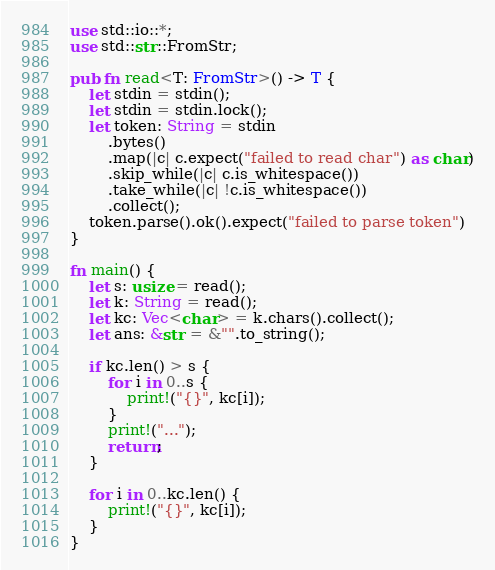Convert code to text. <code><loc_0><loc_0><loc_500><loc_500><_Rust_>use std::io::*;
use std::str::FromStr;

pub fn read<T: FromStr>() -> T {
    let stdin = stdin();
    let stdin = stdin.lock();
    let token: String = stdin
        .bytes()
        .map(|c| c.expect("failed to read char") as char)
        .skip_while(|c| c.is_whitespace())
        .take_while(|c| !c.is_whitespace())
        .collect();
    token.parse().ok().expect("failed to parse token")
}

fn main() {
    let s: usize = read();
    let k: String = read();
    let kc: Vec<char> = k.chars().collect();
    let ans: &str = &"".to_string();

    if kc.len() > s {
        for i in 0..s {
            print!("{}", kc[i]);
        }
        print!("...");
        return;
    }

    for i in 0..kc.len() {
        print!("{}", kc[i]);
    }
}
</code> 